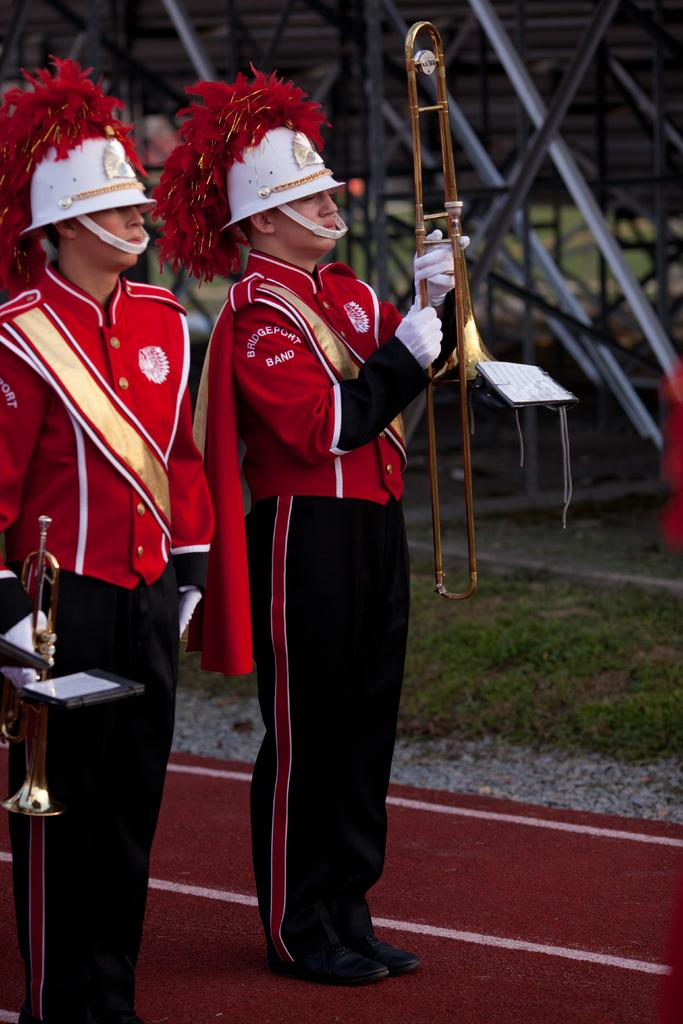Provide a one-sentence caption for the provided image. Membes of the Birdgeport Band stand on a red track ready to start performing. 